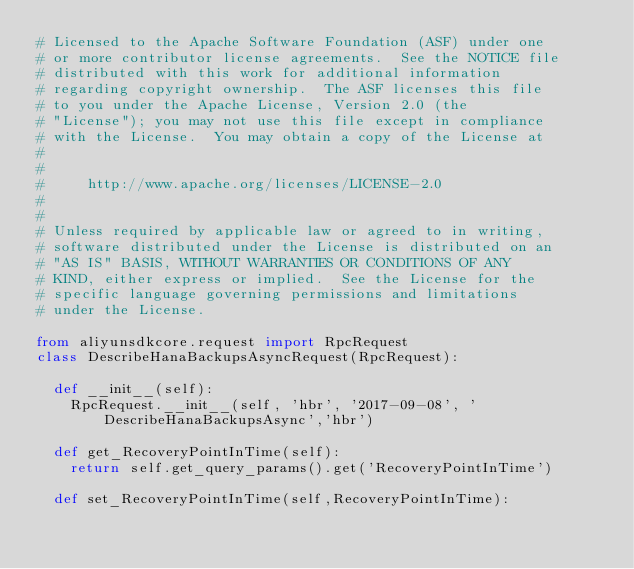<code> <loc_0><loc_0><loc_500><loc_500><_Python_># Licensed to the Apache Software Foundation (ASF) under one
# or more contributor license agreements.  See the NOTICE file
# distributed with this work for additional information
# regarding copyright ownership.  The ASF licenses this file
# to you under the Apache License, Version 2.0 (the
# "License"); you may not use this file except in compliance
# with the License.  You may obtain a copy of the License at
#
#
#     http://www.apache.org/licenses/LICENSE-2.0
#
#
# Unless required by applicable law or agreed to in writing,
# software distributed under the License is distributed on an
# "AS IS" BASIS, WITHOUT WARRANTIES OR CONDITIONS OF ANY
# KIND, either express or implied.  See the License for the
# specific language governing permissions and limitations
# under the License.

from aliyunsdkcore.request import RpcRequest
class DescribeHanaBackupsAsyncRequest(RpcRequest):

	def __init__(self):
		RpcRequest.__init__(self, 'hbr', '2017-09-08', 'DescribeHanaBackupsAsync','hbr')

	def get_RecoveryPointInTime(self):
		return self.get_query_params().get('RecoveryPointInTime')

	def set_RecoveryPointInTime(self,RecoveryPointInTime):</code> 